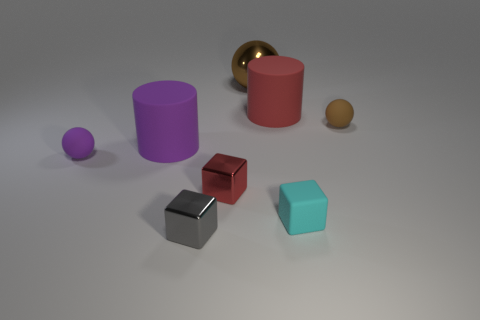Is there any other thing that has the same shape as the brown shiny object?
Offer a terse response. Yes. There is a large matte object in front of the big red matte cylinder; is its color the same as the small rubber ball behind the purple rubber ball?
Provide a short and direct response. No. What number of metallic things are either large purple cylinders or tiny blue cubes?
Your answer should be very brief. 0. Is there any other thing that is the same size as the red cube?
Your answer should be compact. Yes. What is the shape of the large rubber thing behind the big rubber thing to the left of the big brown metal ball?
Your answer should be very brief. Cylinder. Are the small object that is left of the tiny gray shiny cube and the cylinder that is to the right of the big metal sphere made of the same material?
Your response must be concise. Yes. There is a ball on the left side of the big purple object; how many tiny purple rubber balls are in front of it?
Your response must be concise. 0. Do the rubber object that is in front of the red cube and the tiny object behind the tiny purple matte object have the same shape?
Your answer should be compact. No. How big is the rubber thing that is both in front of the brown matte object and right of the gray shiny object?
Provide a short and direct response. Small. What color is the large shiny thing that is the same shape as the small brown matte object?
Keep it short and to the point. Brown. 